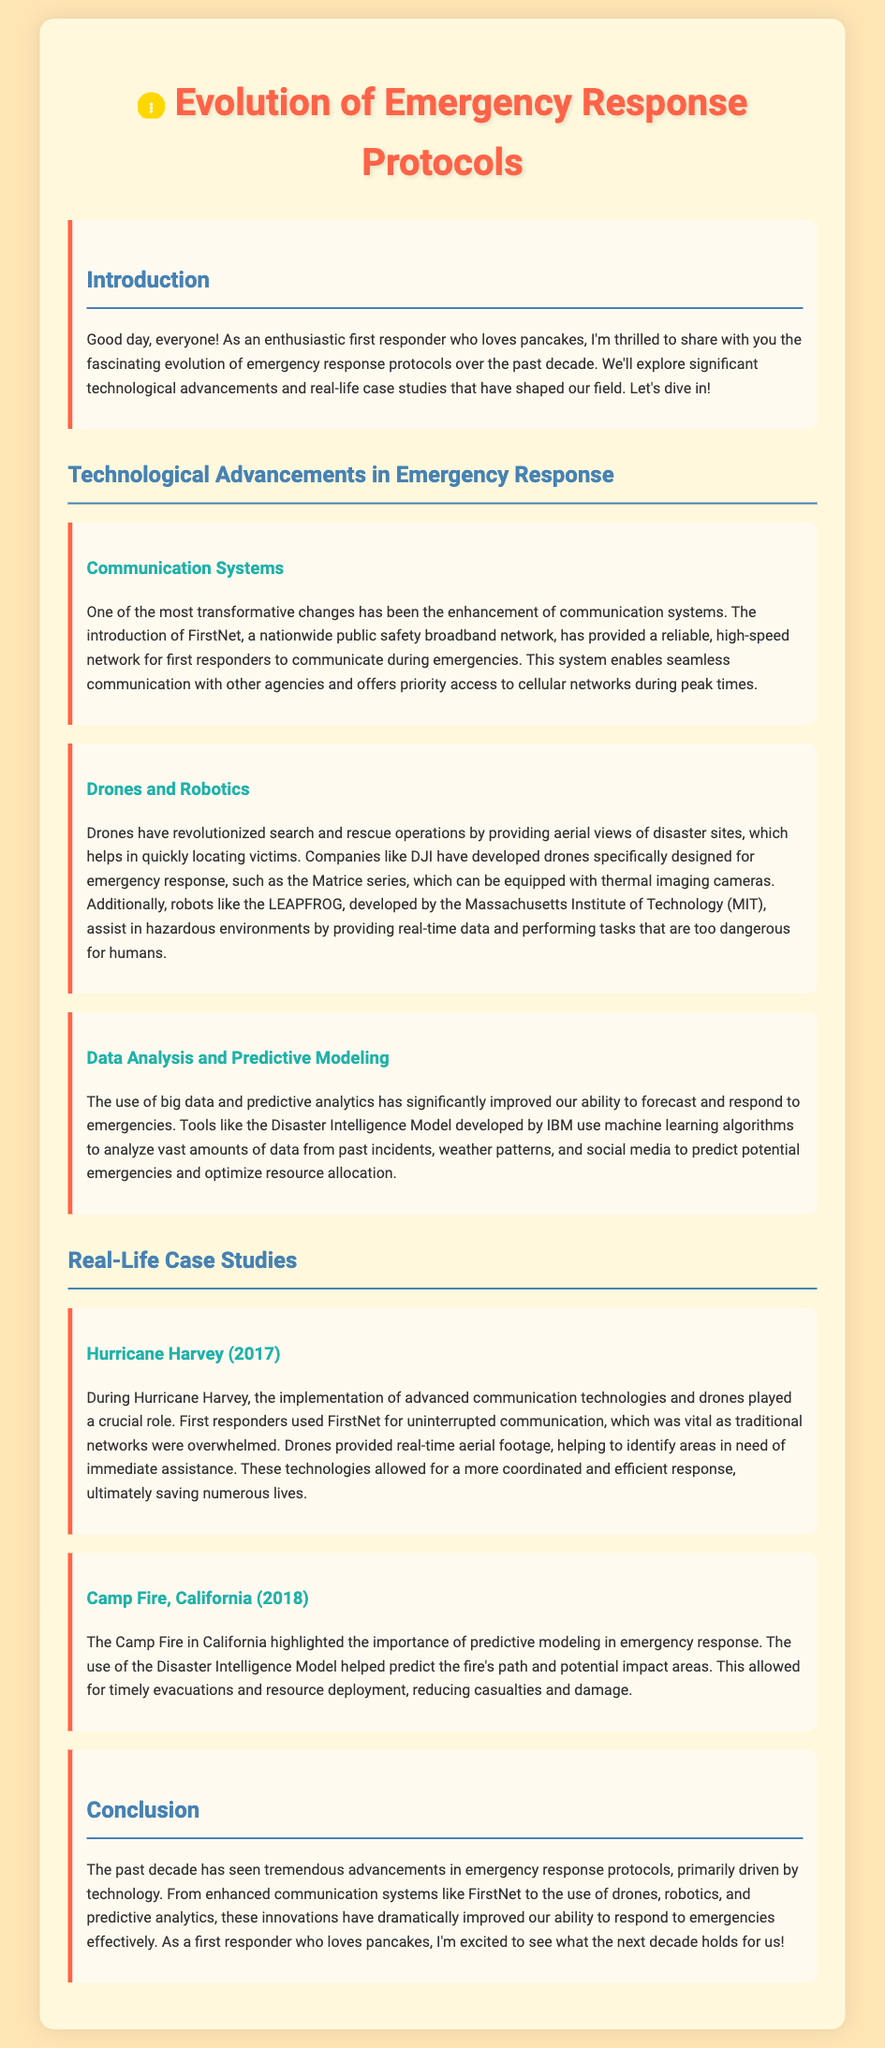What is the title of the document? The title of the document is found in the header section.
Answer: Evolution of Emergency Response Protocols Who developed the Disaster Intelligence Model? The company responsible for the development of this model is mentioned in the context.
Answer: IBM What was implemented during Hurricane Harvey? This event highlighted the use of certain technologies as described in the document.
Answer: advanced communication technologies and drones What technology helps with search and rescue operations? This technology is specifically mentioned in the section about drones.
Answer: Drones In what year did Camp Fire occur in California? The year of this incident is explicitly stated in the document.
Answer: 2018 What is FirstNet? This term refers to a specific advancement related to communication systems as explained in the document.
Answer: a nationwide public safety broadband network What aspect of technology does the document emphasize has improved emergency response? The document discusses these advancements extensively throughout the text.
Answer: communication systems How did drones help during Hurricane Harvey? The document outlines the role of drones during this emergency situation.
Answer: provided real-time aerial footage What is the focus of the introduction section? The introduction sets the tone for the exploration of the document’s main topics.
Answer: the evolution of emergency response protocols What color is used for the main title? This detail relates to the visual aspects of the document's design.
Answer: #FF6347 